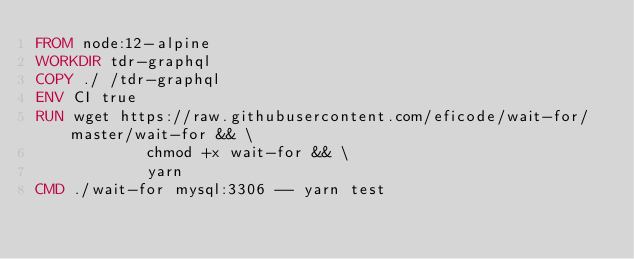Convert code to text. <code><loc_0><loc_0><loc_500><loc_500><_Dockerfile_>FROM node:12-alpine
WORKDIR tdr-graphql
COPY ./ /tdr-graphql
ENV CI true
RUN wget https://raw.githubusercontent.com/eficode/wait-for/master/wait-for && \
            chmod +x wait-for && \ 
            yarn
CMD ./wait-for mysql:3306 -- yarn test</code> 